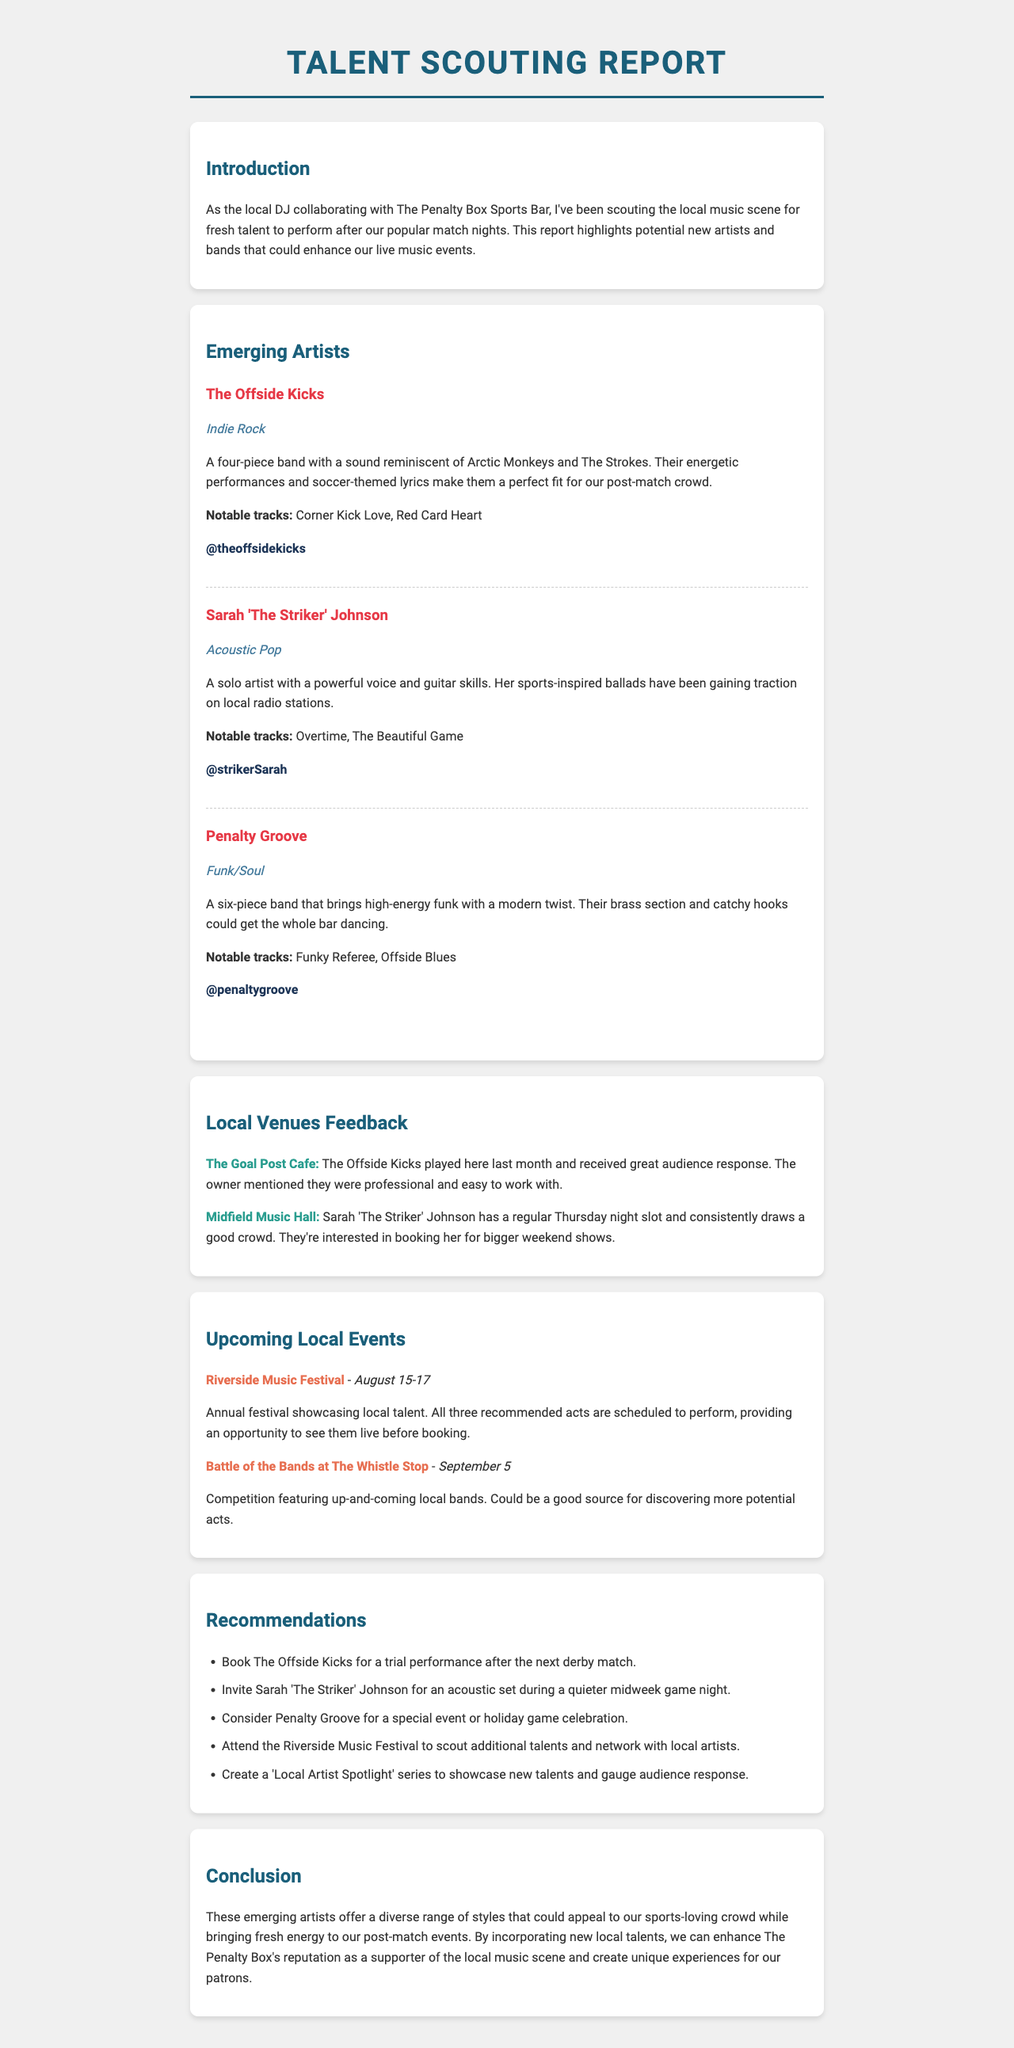What is the name of the first emerging artist? The first emerging artist listed in the report is The Offside Kicks.
Answer: The Offside Kicks What genre does Sarah 'The Striker' Johnson perform? Sarah 'The Striker' Johnson is classified under the Acoustic Pop genre.
Answer: Acoustic Pop Which venue provided positive feedback for The Offside Kicks? The Goal Post Cafe gave great feedback regarding The Offside Kicks' performance.
Answer: The Goal Post Cafe What is the date of the Riverside Music Festival? The Riverside Music Festival is scheduled from August 15 to August 17.
Answer: August 15-17 How many notable tracks does Penalty Groove have listed? Penalty Groove has two notable tracks mentioned in the report.
Answer: Two What is one of the recommendations made in the report? One recommendation is to book The Offside Kicks for a trial performance after the next derby match.
Answer: Book The Offside Kicks for a trial performance after the next derby match What kind of series is suggested to showcase new talents? The report recommends creating a 'Local Artist Spotlight' series.
Answer: Local Artist Spotlight series Which emerging artist has been gaining traction on local radio stations? Sarah 'The Striker' Johnson has been gaining traction on local radio stations.
Answer: Sarah 'The Striker' Johnson What type of event is scheduled on September 5? The scheduled event on September 5 is the Battle of the Bands at The Whistle Stop.
Answer: Battle of the Bands at The Whistle Stop 